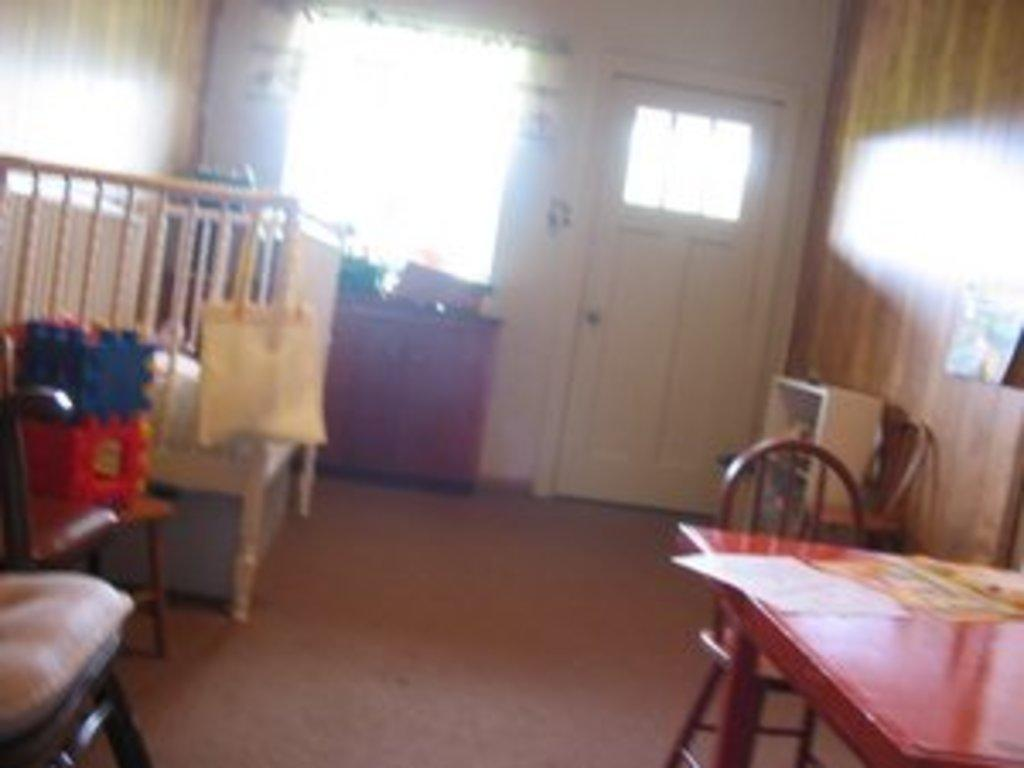What type of space is depicted in the image? The image shows an inside view of a room. What furniture is present in the room? There are chairs and a table in the room. Are there any other objects in the room besides furniture? Yes, there are other objects in the room. What specific object related to a baby can be seen in the room? There is a baby crib bumper in the room. What architectural features are present in the room? There is a window and a door in the room. How many snails can be seen crawling on the table in the image? There are no snails present in the image; the table is not shown to have any snails on it. 